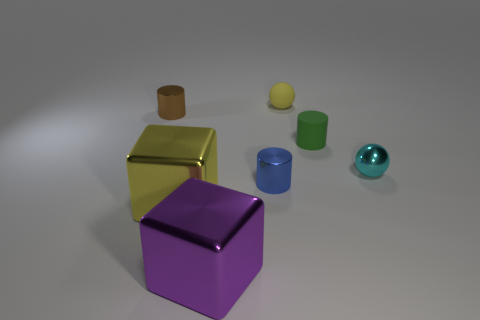What number of other things are there of the same shape as the cyan metal object?
Offer a very short reply. 1. Is the number of purple metallic blocks greater than the number of large red rubber cubes?
Your answer should be compact. Yes. There is a yellow object that is to the left of the metal cylinder on the right side of the yellow metal cube; what is its shape?
Offer a very short reply. Cube. Are there more large things behind the large purple metal thing than big brown objects?
Make the answer very short. Yes. What number of big yellow shiny cubes are behind the small rubber object in front of the tiny rubber ball?
Your answer should be very brief. 0. Are the cylinder that is to the left of the yellow block and the small cylinder that is in front of the tiny metal ball made of the same material?
Give a very brief answer. Yes. There is a cube that is the same color as the rubber ball; what material is it?
Give a very brief answer. Metal. How many tiny brown things have the same shape as the blue metallic thing?
Your answer should be very brief. 1. Is the blue object made of the same material as the ball left of the green rubber thing?
Your answer should be compact. No. There is a blue object that is the same size as the cyan thing; what material is it?
Your response must be concise. Metal. 